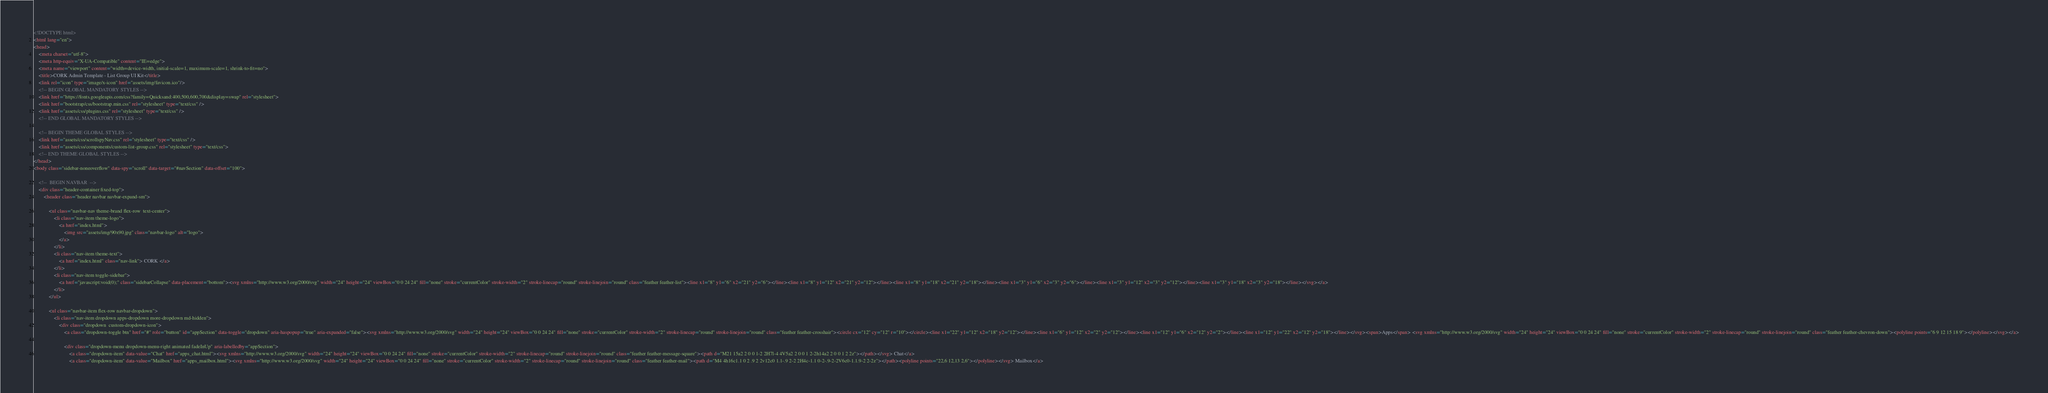Convert code to text. <code><loc_0><loc_0><loc_500><loc_500><_HTML_><!DOCTYPE html>
<html lang="en">
<head>
    <meta charset="utf-8">
    <meta http-equiv="X-UA-Compatible" content="IE=edge">
    <meta name="viewport" content="width=device-width, initial-scale=1, maximum-scale=1, shrink-to-fit=no">
    <title>CORK Admin Template - List Group UI Kit</title>
    <link rel="icon" type="image/x-icon" href="assets/img/favicon.ico"/>
    <!-- BEGIN GLOBAL MANDATORY STYLES -->
    <link href="https://fonts.googleapis.com/css?family=Quicksand:400,500,600,700&display=swap" rel="stylesheet">
    <link href="bootstrap/css/bootstrap.min.css" rel="stylesheet" type="text/css" />
    <link href="assets/css/plugins.css" rel="stylesheet" type="text/css" />
    <!-- END GLOBAL MANDATORY STYLES -->

    <!-- BEGIN THEME GLOBAL STYLES -->
    <link href="assets/css/scrollspyNav.css" rel="stylesheet" type="text/css" />
    <link href="assets/css/components/custom-list-group.css" rel="stylesheet" type="text/css">
    <!-- END THEME GLOBAL STYLES -->
</head>
<body class="sidebar-noneoverflow" data-spy="scroll" data-target="#navSection" data-offset="100">
    
    <!--  BEGIN NAVBAR  -->
    <div class="header-container fixed-top">
        <header class="header navbar navbar-expand-sm">
            
            <ul class="navbar-nav theme-brand flex-row  text-center">
                <li class="nav-item theme-logo">
                    <a href="index.html">
                        <img src="assets/img/90x90.jpg" class="navbar-logo" alt="logo">
                    </a>
                </li>
                <li class="nav-item theme-text">
                    <a href="index.html" class="nav-link"> CORK </a>
                </li>
                <li class="nav-item toggle-sidebar">
                    <a href="javascript:void(0);" class="sidebarCollapse" data-placement="bottom"><svg xmlns="http://www.w3.org/2000/svg" width="24" height="24" viewBox="0 0 24 24" fill="none" stroke="currentColor" stroke-width="2" stroke-linecap="round" stroke-linejoin="round" class="feather feather-list"><line x1="8" y1="6" x2="21" y2="6"></line><line x1="8" y1="12" x2="21" y2="12"></line><line x1="8" y1="18" x2="21" y2="18"></line><line x1="3" y1="6" x2="3" y2="6"></line><line x1="3" y1="12" x2="3" y2="12"></line><line x1="3" y1="18" x2="3" y2="18"></line></svg></a>
                </li>
            </ul>

            <ul class="navbar-item flex-row navbar-dropdown">
                <li class="nav-item dropdown apps-dropdown more-dropdown md-hidden">
                    <div class="dropdown  custom-dropdown-icon">
                        <a class="dropdown-toggle btn" href="#" role="button" id="appSection" data-toggle="dropdown" aria-haspopup="true" aria-expanded="false"><svg xmlns="http://www.w3.org/2000/svg" width="24" height="24" viewBox="0 0 24 24" fill="none" stroke="currentColor" stroke-width="2" stroke-linecap="round" stroke-linejoin="round" class="feather feather-crosshair"><circle cx="12" cy="12" r="10"></circle><line x1="22" y1="12" x2="18" y2="12"></line><line x1="6" y1="12" x2="2" y2="12"></line><line x1="12" y1="6" x2="12" y2="2"></line><line x1="12" y1="22" x2="12" y2="18"></line></svg><span>Apps</span> <svg xmlns="http://www.w3.org/2000/svg" width="24" height="24" viewBox="0 0 24 24" fill="none" stroke="currentColor" stroke-width="2" stroke-linecap="round" stroke-linejoin="round" class="feather feather-chevron-down"><polyline points="6 9 12 15 18 9"></polyline></svg></a>

                        <div class="dropdown-menu dropdown-menu-right animated fadeInUp" aria-labelledby="appSection">
                            <a class="dropdown-item" data-value="Chat" href="apps_chat.html"><svg xmlns="http://www.w3.org/2000/svg" width="24" height="24" viewBox="0 0 24 24" fill="none" stroke="currentColor" stroke-width="2" stroke-linecap="round" stroke-linejoin="round" class="feather feather-message-square"><path d="M21 15a2 2 0 0 1-2 2H7l-4 4V5a2 2 0 0 1 2-2h14a2 2 0 0 1 2 2z"></path></svg> Chat</a>
                            <a class="dropdown-item" data-value="Mailbox" href="apps_mailbox.html"><svg xmlns="http://www.w3.org/2000/svg" width="24" height="24" viewBox="0 0 24 24" fill="none" stroke="currentColor" stroke-width="2" stroke-linecap="round" stroke-linejoin="round" class="feather feather-mail"><path d="M4 4h16c1.1 0 2 .9 2 2v12c0 1.1-.9 2-2 2H4c-1.1 0-2-.9-2-2V6c0-1.1.9-2 2-2z"></path><polyline points="22,6 12,13 2,6"></polyline></svg> Mailbox</a></code> 